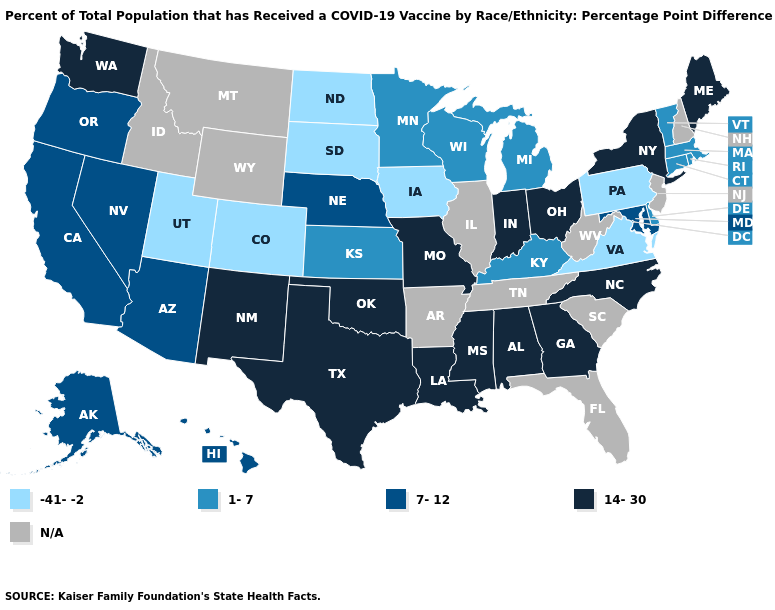Name the states that have a value in the range 7-12?
Be succinct. Alaska, Arizona, California, Hawaii, Maryland, Nebraska, Nevada, Oregon. Does Georgia have the lowest value in the South?
Keep it brief. No. Name the states that have a value in the range 1-7?
Write a very short answer. Connecticut, Delaware, Kansas, Kentucky, Massachusetts, Michigan, Minnesota, Rhode Island, Vermont, Wisconsin. What is the value of Missouri?
Quick response, please. 14-30. What is the value of Florida?
Short answer required. N/A. Name the states that have a value in the range 7-12?
Give a very brief answer. Alaska, Arizona, California, Hawaii, Maryland, Nebraska, Nevada, Oregon. Among the states that border Massachusetts , which have the highest value?
Write a very short answer. New York. What is the value of South Dakota?
Short answer required. -41--2. What is the value of Florida?
Write a very short answer. N/A. Does Alaska have the highest value in the West?
Write a very short answer. No. What is the value of Delaware?
Concise answer only. 1-7. What is the value of Ohio?
Be succinct. 14-30. Does Colorado have the highest value in the USA?
Give a very brief answer. No. What is the lowest value in states that border Montana?
Be succinct. -41--2. 